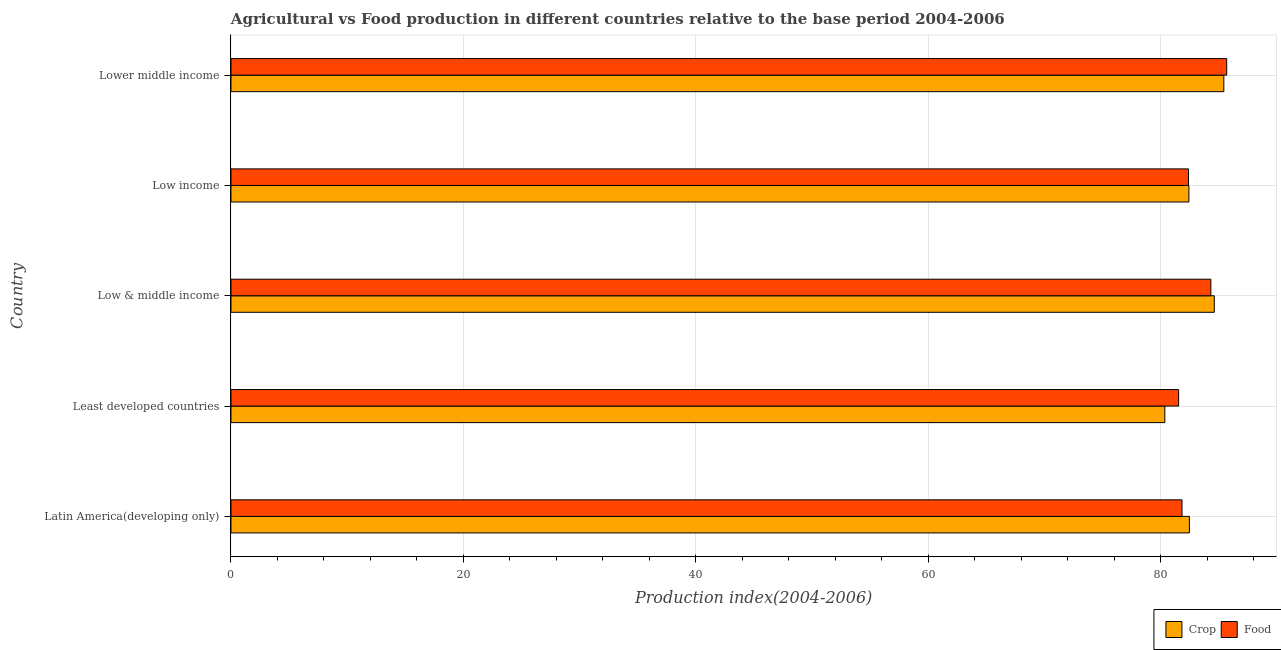How many different coloured bars are there?
Your answer should be very brief. 2. How many groups of bars are there?
Your answer should be compact. 5. Are the number of bars on each tick of the Y-axis equal?
Make the answer very short. Yes. How many bars are there on the 4th tick from the top?
Your answer should be very brief. 2. How many bars are there on the 1st tick from the bottom?
Keep it short and to the point. 2. What is the label of the 2nd group of bars from the top?
Give a very brief answer. Low income. What is the crop production index in Lower middle income?
Provide a succinct answer. 85.44. Across all countries, what is the maximum food production index?
Keep it short and to the point. 85.69. Across all countries, what is the minimum crop production index?
Provide a succinct answer. 80.36. In which country was the crop production index maximum?
Your answer should be compact. Lower middle income. In which country was the food production index minimum?
Keep it short and to the point. Least developed countries. What is the total crop production index in the graph?
Your response must be concise. 415.34. What is the difference between the crop production index in Latin America(developing only) and that in Low income?
Offer a terse response. 0.04. What is the difference between the crop production index in Low & middle income and the food production index in Low income?
Provide a short and direct response. 2.22. What is the average crop production index per country?
Your response must be concise. 83.07. What is the difference between the crop production index and food production index in Latin America(developing only)?
Provide a short and direct response. 0.64. Is the crop production index in Least developed countries less than that in Lower middle income?
Keep it short and to the point. Yes. Is the difference between the food production index in Latin America(developing only) and Low & middle income greater than the difference between the crop production index in Latin America(developing only) and Low & middle income?
Make the answer very short. No. What is the difference between the highest and the second highest crop production index?
Offer a terse response. 0.82. What is the difference between the highest and the lowest crop production index?
Keep it short and to the point. 5.08. What does the 1st bar from the top in Lower middle income represents?
Keep it short and to the point. Food. What does the 1st bar from the bottom in Low income represents?
Your answer should be very brief. Crop. Are all the bars in the graph horizontal?
Your answer should be compact. Yes. Does the graph contain any zero values?
Your answer should be very brief. No. What is the title of the graph?
Provide a succinct answer. Agricultural vs Food production in different countries relative to the base period 2004-2006. Does "Netherlands" appear as one of the legend labels in the graph?
Ensure brevity in your answer.  No. What is the label or title of the X-axis?
Your response must be concise. Production index(2004-2006). What is the label or title of the Y-axis?
Give a very brief answer. Country. What is the Production index(2004-2006) of Crop in Latin America(developing only)?
Give a very brief answer. 82.48. What is the Production index(2004-2006) in Food in Latin America(developing only)?
Make the answer very short. 81.84. What is the Production index(2004-2006) of Crop in Least developed countries?
Provide a succinct answer. 80.36. What is the Production index(2004-2006) in Food in Least developed countries?
Keep it short and to the point. 81.55. What is the Production index(2004-2006) in Crop in Low & middle income?
Offer a very short reply. 84.62. What is the Production index(2004-2006) of Food in Low & middle income?
Your answer should be very brief. 84.32. What is the Production index(2004-2006) in Crop in Low income?
Ensure brevity in your answer.  82.43. What is the Production index(2004-2006) in Food in Low income?
Your response must be concise. 82.4. What is the Production index(2004-2006) of Crop in Lower middle income?
Offer a very short reply. 85.44. What is the Production index(2004-2006) of Food in Lower middle income?
Provide a succinct answer. 85.69. Across all countries, what is the maximum Production index(2004-2006) in Crop?
Offer a terse response. 85.44. Across all countries, what is the maximum Production index(2004-2006) in Food?
Give a very brief answer. 85.69. Across all countries, what is the minimum Production index(2004-2006) in Crop?
Provide a succinct answer. 80.36. Across all countries, what is the minimum Production index(2004-2006) in Food?
Provide a short and direct response. 81.55. What is the total Production index(2004-2006) of Crop in the graph?
Provide a short and direct response. 415.34. What is the total Production index(2004-2006) in Food in the graph?
Your answer should be very brief. 415.81. What is the difference between the Production index(2004-2006) in Crop in Latin America(developing only) and that in Least developed countries?
Keep it short and to the point. 2.11. What is the difference between the Production index(2004-2006) in Food in Latin America(developing only) and that in Least developed countries?
Offer a terse response. 0.29. What is the difference between the Production index(2004-2006) in Crop in Latin America(developing only) and that in Low & middle income?
Give a very brief answer. -2.14. What is the difference between the Production index(2004-2006) in Food in Latin America(developing only) and that in Low & middle income?
Your response must be concise. -2.48. What is the difference between the Production index(2004-2006) in Crop in Latin America(developing only) and that in Low income?
Keep it short and to the point. 0.04. What is the difference between the Production index(2004-2006) in Food in Latin America(developing only) and that in Low income?
Give a very brief answer. -0.56. What is the difference between the Production index(2004-2006) of Crop in Latin America(developing only) and that in Lower middle income?
Ensure brevity in your answer.  -2.96. What is the difference between the Production index(2004-2006) in Food in Latin America(developing only) and that in Lower middle income?
Provide a short and direct response. -3.85. What is the difference between the Production index(2004-2006) of Crop in Least developed countries and that in Low & middle income?
Provide a short and direct response. -4.26. What is the difference between the Production index(2004-2006) in Food in Least developed countries and that in Low & middle income?
Your response must be concise. -2.77. What is the difference between the Production index(2004-2006) in Crop in Least developed countries and that in Low income?
Provide a short and direct response. -2.07. What is the difference between the Production index(2004-2006) in Food in Least developed countries and that in Low income?
Offer a very short reply. -0.85. What is the difference between the Production index(2004-2006) in Crop in Least developed countries and that in Lower middle income?
Your answer should be compact. -5.08. What is the difference between the Production index(2004-2006) of Food in Least developed countries and that in Lower middle income?
Ensure brevity in your answer.  -4.14. What is the difference between the Production index(2004-2006) in Crop in Low & middle income and that in Low income?
Ensure brevity in your answer.  2.19. What is the difference between the Production index(2004-2006) of Food in Low & middle income and that in Low income?
Provide a succinct answer. 1.92. What is the difference between the Production index(2004-2006) of Crop in Low & middle income and that in Lower middle income?
Give a very brief answer. -0.82. What is the difference between the Production index(2004-2006) in Food in Low & middle income and that in Lower middle income?
Offer a terse response. -1.37. What is the difference between the Production index(2004-2006) in Crop in Low income and that in Lower middle income?
Offer a terse response. -3.01. What is the difference between the Production index(2004-2006) in Food in Low income and that in Lower middle income?
Offer a terse response. -3.29. What is the difference between the Production index(2004-2006) in Crop in Latin America(developing only) and the Production index(2004-2006) in Food in Least developed countries?
Your answer should be compact. 0.93. What is the difference between the Production index(2004-2006) in Crop in Latin America(developing only) and the Production index(2004-2006) in Food in Low & middle income?
Provide a succinct answer. -1.85. What is the difference between the Production index(2004-2006) of Crop in Latin America(developing only) and the Production index(2004-2006) of Food in Low income?
Ensure brevity in your answer.  0.08. What is the difference between the Production index(2004-2006) of Crop in Latin America(developing only) and the Production index(2004-2006) of Food in Lower middle income?
Your answer should be compact. -3.21. What is the difference between the Production index(2004-2006) of Crop in Least developed countries and the Production index(2004-2006) of Food in Low & middle income?
Offer a terse response. -3.96. What is the difference between the Production index(2004-2006) in Crop in Least developed countries and the Production index(2004-2006) in Food in Low income?
Your answer should be compact. -2.04. What is the difference between the Production index(2004-2006) in Crop in Least developed countries and the Production index(2004-2006) in Food in Lower middle income?
Ensure brevity in your answer.  -5.32. What is the difference between the Production index(2004-2006) of Crop in Low & middle income and the Production index(2004-2006) of Food in Low income?
Offer a very short reply. 2.22. What is the difference between the Production index(2004-2006) in Crop in Low & middle income and the Production index(2004-2006) in Food in Lower middle income?
Your response must be concise. -1.07. What is the difference between the Production index(2004-2006) of Crop in Low income and the Production index(2004-2006) of Food in Lower middle income?
Make the answer very short. -3.25. What is the average Production index(2004-2006) in Crop per country?
Ensure brevity in your answer.  83.07. What is the average Production index(2004-2006) of Food per country?
Keep it short and to the point. 83.16. What is the difference between the Production index(2004-2006) in Crop and Production index(2004-2006) in Food in Latin America(developing only)?
Your response must be concise. 0.64. What is the difference between the Production index(2004-2006) of Crop and Production index(2004-2006) of Food in Least developed countries?
Make the answer very short. -1.19. What is the difference between the Production index(2004-2006) in Crop and Production index(2004-2006) in Food in Low & middle income?
Your answer should be very brief. 0.3. What is the difference between the Production index(2004-2006) in Crop and Production index(2004-2006) in Food in Low income?
Make the answer very short. 0.03. What is the difference between the Production index(2004-2006) of Crop and Production index(2004-2006) of Food in Lower middle income?
Offer a very short reply. -0.25. What is the ratio of the Production index(2004-2006) of Crop in Latin America(developing only) to that in Least developed countries?
Make the answer very short. 1.03. What is the ratio of the Production index(2004-2006) in Crop in Latin America(developing only) to that in Low & middle income?
Offer a very short reply. 0.97. What is the ratio of the Production index(2004-2006) in Food in Latin America(developing only) to that in Low & middle income?
Offer a very short reply. 0.97. What is the ratio of the Production index(2004-2006) of Food in Latin America(developing only) to that in Low income?
Keep it short and to the point. 0.99. What is the ratio of the Production index(2004-2006) in Crop in Latin America(developing only) to that in Lower middle income?
Offer a terse response. 0.97. What is the ratio of the Production index(2004-2006) in Food in Latin America(developing only) to that in Lower middle income?
Offer a very short reply. 0.96. What is the ratio of the Production index(2004-2006) of Crop in Least developed countries to that in Low & middle income?
Give a very brief answer. 0.95. What is the ratio of the Production index(2004-2006) of Food in Least developed countries to that in Low & middle income?
Your answer should be compact. 0.97. What is the ratio of the Production index(2004-2006) of Crop in Least developed countries to that in Low income?
Keep it short and to the point. 0.97. What is the ratio of the Production index(2004-2006) of Crop in Least developed countries to that in Lower middle income?
Keep it short and to the point. 0.94. What is the ratio of the Production index(2004-2006) in Food in Least developed countries to that in Lower middle income?
Your answer should be compact. 0.95. What is the ratio of the Production index(2004-2006) in Crop in Low & middle income to that in Low income?
Your answer should be compact. 1.03. What is the ratio of the Production index(2004-2006) of Food in Low & middle income to that in Low income?
Offer a terse response. 1.02. What is the ratio of the Production index(2004-2006) in Food in Low & middle income to that in Lower middle income?
Give a very brief answer. 0.98. What is the ratio of the Production index(2004-2006) of Crop in Low income to that in Lower middle income?
Offer a terse response. 0.96. What is the ratio of the Production index(2004-2006) of Food in Low income to that in Lower middle income?
Your response must be concise. 0.96. What is the difference between the highest and the second highest Production index(2004-2006) in Crop?
Keep it short and to the point. 0.82. What is the difference between the highest and the second highest Production index(2004-2006) of Food?
Provide a succinct answer. 1.37. What is the difference between the highest and the lowest Production index(2004-2006) in Crop?
Offer a very short reply. 5.08. What is the difference between the highest and the lowest Production index(2004-2006) of Food?
Keep it short and to the point. 4.14. 